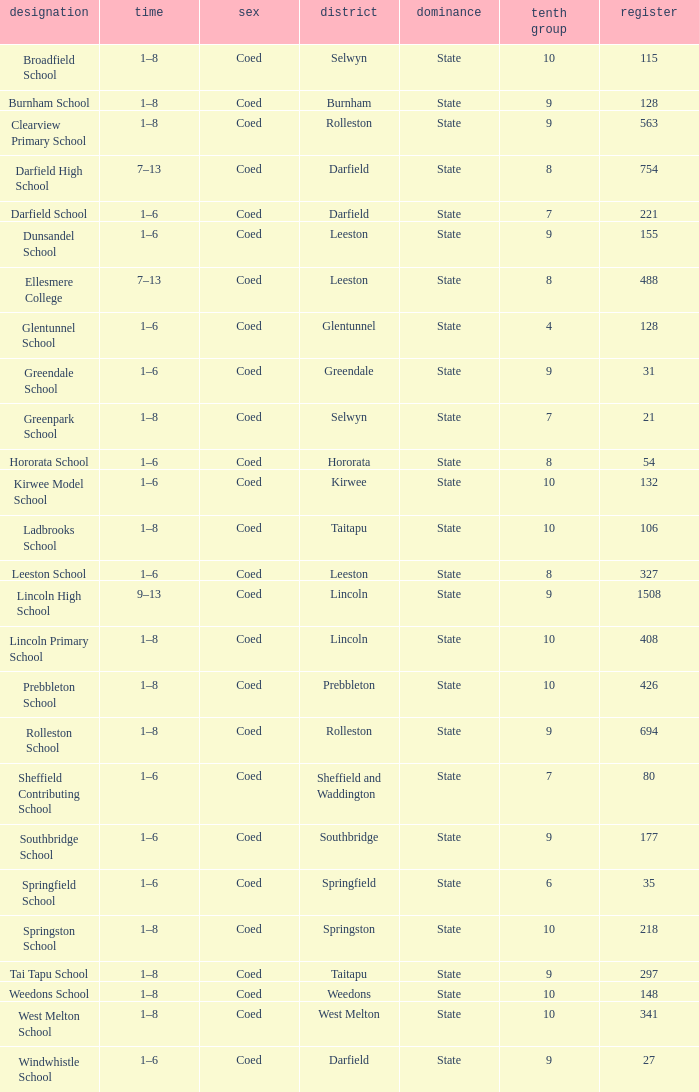How many deciles have Years of 9–13? 1.0. 